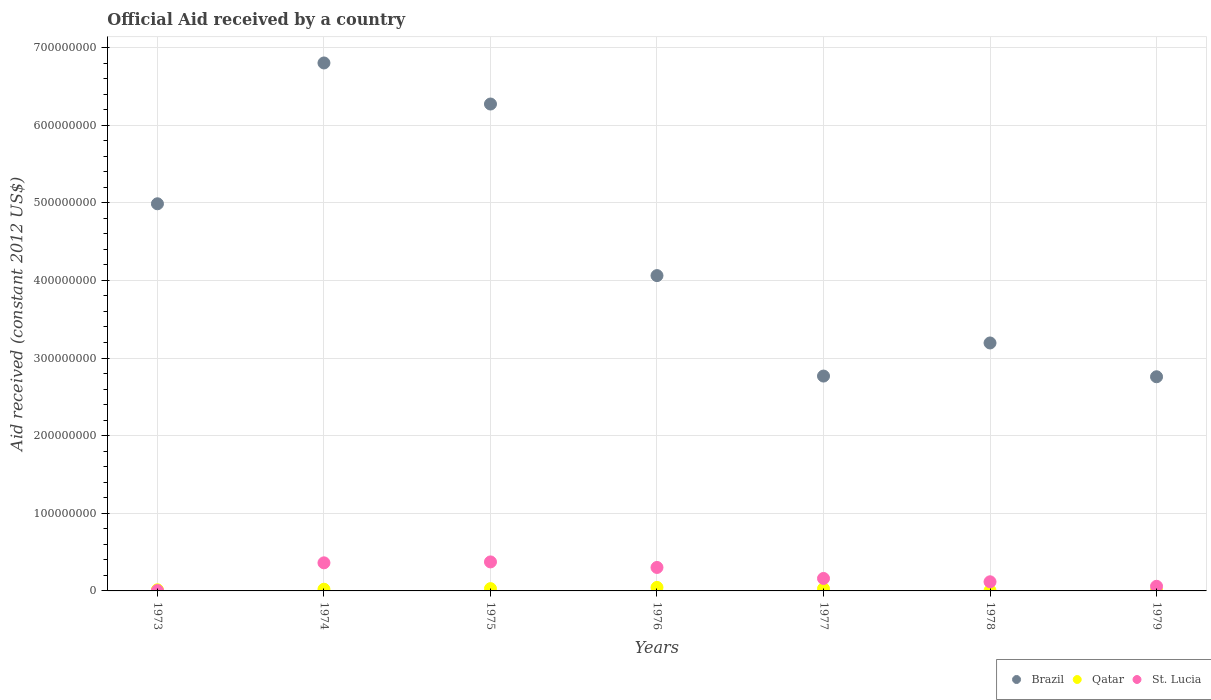How many different coloured dotlines are there?
Keep it short and to the point. 3. Is the number of dotlines equal to the number of legend labels?
Make the answer very short. Yes. What is the net official aid received in St. Lucia in 1974?
Your response must be concise. 3.62e+07. Across all years, what is the maximum net official aid received in Qatar?
Ensure brevity in your answer.  4.52e+06. In which year was the net official aid received in Brazil maximum?
Ensure brevity in your answer.  1974. In which year was the net official aid received in Brazil minimum?
Provide a short and direct response. 1979. What is the total net official aid received in St. Lucia in the graph?
Make the answer very short. 1.38e+08. What is the difference between the net official aid received in Qatar in 1973 and that in 1978?
Make the answer very short. 1.04e+06. What is the difference between the net official aid received in St. Lucia in 1979 and the net official aid received in Brazil in 1978?
Ensure brevity in your answer.  -3.13e+08. What is the average net official aid received in Qatar per year?
Keep it short and to the point. 2.12e+06. In the year 1973, what is the difference between the net official aid received in St. Lucia and net official aid received in Qatar?
Offer a terse response. -1.01e+06. In how many years, is the net official aid received in Brazil greater than 340000000 US$?
Ensure brevity in your answer.  4. What is the ratio of the net official aid received in Brazil in 1973 to that in 1978?
Offer a very short reply. 1.56. What is the difference between the highest and the second highest net official aid received in St. Lucia?
Your answer should be very brief. 1.19e+06. What is the difference between the highest and the lowest net official aid received in Brazil?
Give a very brief answer. 4.04e+08. In how many years, is the net official aid received in St. Lucia greater than the average net official aid received in St. Lucia taken over all years?
Make the answer very short. 3. Is it the case that in every year, the sum of the net official aid received in St. Lucia and net official aid received in Brazil  is greater than the net official aid received in Qatar?
Make the answer very short. Yes. Does the net official aid received in St. Lucia monotonically increase over the years?
Make the answer very short. No. How many years are there in the graph?
Keep it short and to the point. 7. What is the difference between two consecutive major ticks on the Y-axis?
Keep it short and to the point. 1.00e+08. Does the graph contain any zero values?
Your answer should be compact. No. Does the graph contain grids?
Offer a terse response. Yes. Where does the legend appear in the graph?
Make the answer very short. Bottom right. What is the title of the graph?
Offer a very short reply. Official Aid received by a country. Does "Dominica" appear as one of the legend labels in the graph?
Offer a very short reply. No. What is the label or title of the Y-axis?
Keep it short and to the point. Aid received (constant 2012 US$). What is the Aid received (constant 2012 US$) in Brazil in 1973?
Give a very brief answer. 4.99e+08. What is the Aid received (constant 2012 US$) of Qatar in 1973?
Provide a succinct answer. 1.44e+06. What is the Aid received (constant 2012 US$) in St. Lucia in 1973?
Provide a succinct answer. 4.30e+05. What is the Aid received (constant 2012 US$) of Brazil in 1974?
Ensure brevity in your answer.  6.80e+08. What is the Aid received (constant 2012 US$) of Qatar in 1974?
Make the answer very short. 2.20e+06. What is the Aid received (constant 2012 US$) in St. Lucia in 1974?
Make the answer very short. 3.62e+07. What is the Aid received (constant 2012 US$) in Brazil in 1975?
Your response must be concise. 6.27e+08. What is the Aid received (constant 2012 US$) of Qatar in 1975?
Provide a succinct answer. 2.96e+06. What is the Aid received (constant 2012 US$) of St. Lucia in 1975?
Offer a very short reply. 3.74e+07. What is the Aid received (constant 2012 US$) in Brazil in 1976?
Provide a short and direct response. 4.06e+08. What is the Aid received (constant 2012 US$) of Qatar in 1976?
Provide a succinct answer. 4.52e+06. What is the Aid received (constant 2012 US$) in St. Lucia in 1976?
Offer a terse response. 3.02e+07. What is the Aid received (constant 2012 US$) in Brazil in 1977?
Make the answer very short. 2.77e+08. What is the Aid received (constant 2012 US$) of Qatar in 1977?
Provide a short and direct response. 2.86e+06. What is the Aid received (constant 2012 US$) in St. Lucia in 1977?
Offer a very short reply. 1.61e+07. What is the Aid received (constant 2012 US$) in Brazil in 1978?
Offer a very short reply. 3.19e+08. What is the Aid received (constant 2012 US$) in Qatar in 1978?
Your answer should be very brief. 4.00e+05. What is the Aid received (constant 2012 US$) of St. Lucia in 1978?
Your answer should be compact. 1.18e+07. What is the Aid received (constant 2012 US$) in Brazil in 1979?
Your answer should be very brief. 2.76e+08. What is the Aid received (constant 2012 US$) in Qatar in 1979?
Provide a succinct answer. 4.40e+05. What is the Aid received (constant 2012 US$) in St. Lucia in 1979?
Offer a very short reply. 5.97e+06. Across all years, what is the maximum Aid received (constant 2012 US$) in Brazil?
Give a very brief answer. 6.80e+08. Across all years, what is the maximum Aid received (constant 2012 US$) of Qatar?
Your answer should be very brief. 4.52e+06. Across all years, what is the maximum Aid received (constant 2012 US$) in St. Lucia?
Provide a succinct answer. 3.74e+07. Across all years, what is the minimum Aid received (constant 2012 US$) of Brazil?
Provide a short and direct response. 2.76e+08. Across all years, what is the minimum Aid received (constant 2012 US$) in Qatar?
Keep it short and to the point. 4.00e+05. What is the total Aid received (constant 2012 US$) in Brazil in the graph?
Make the answer very short. 3.08e+09. What is the total Aid received (constant 2012 US$) in Qatar in the graph?
Offer a very short reply. 1.48e+07. What is the total Aid received (constant 2012 US$) in St. Lucia in the graph?
Give a very brief answer. 1.38e+08. What is the difference between the Aid received (constant 2012 US$) in Brazil in 1973 and that in 1974?
Provide a short and direct response. -1.81e+08. What is the difference between the Aid received (constant 2012 US$) of Qatar in 1973 and that in 1974?
Provide a short and direct response. -7.60e+05. What is the difference between the Aid received (constant 2012 US$) in St. Lucia in 1973 and that in 1974?
Provide a short and direct response. -3.58e+07. What is the difference between the Aid received (constant 2012 US$) in Brazil in 1973 and that in 1975?
Your response must be concise. -1.28e+08. What is the difference between the Aid received (constant 2012 US$) in Qatar in 1973 and that in 1975?
Your answer should be very brief. -1.52e+06. What is the difference between the Aid received (constant 2012 US$) in St. Lucia in 1973 and that in 1975?
Offer a terse response. -3.69e+07. What is the difference between the Aid received (constant 2012 US$) in Brazil in 1973 and that in 1976?
Provide a succinct answer. 9.25e+07. What is the difference between the Aid received (constant 2012 US$) of Qatar in 1973 and that in 1976?
Your answer should be very brief. -3.08e+06. What is the difference between the Aid received (constant 2012 US$) in St. Lucia in 1973 and that in 1976?
Give a very brief answer. -2.98e+07. What is the difference between the Aid received (constant 2012 US$) of Brazil in 1973 and that in 1977?
Provide a succinct answer. 2.22e+08. What is the difference between the Aid received (constant 2012 US$) in Qatar in 1973 and that in 1977?
Keep it short and to the point. -1.42e+06. What is the difference between the Aid received (constant 2012 US$) in St. Lucia in 1973 and that in 1977?
Your answer should be compact. -1.56e+07. What is the difference between the Aid received (constant 2012 US$) of Brazil in 1973 and that in 1978?
Offer a terse response. 1.79e+08. What is the difference between the Aid received (constant 2012 US$) in Qatar in 1973 and that in 1978?
Provide a short and direct response. 1.04e+06. What is the difference between the Aid received (constant 2012 US$) in St. Lucia in 1973 and that in 1978?
Ensure brevity in your answer.  -1.13e+07. What is the difference between the Aid received (constant 2012 US$) of Brazil in 1973 and that in 1979?
Give a very brief answer. 2.23e+08. What is the difference between the Aid received (constant 2012 US$) in Qatar in 1973 and that in 1979?
Your response must be concise. 1.00e+06. What is the difference between the Aid received (constant 2012 US$) of St. Lucia in 1973 and that in 1979?
Your answer should be very brief. -5.54e+06. What is the difference between the Aid received (constant 2012 US$) in Brazil in 1974 and that in 1975?
Give a very brief answer. 5.29e+07. What is the difference between the Aid received (constant 2012 US$) in Qatar in 1974 and that in 1975?
Offer a very short reply. -7.60e+05. What is the difference between the Aid received (constant 2012 US$) in St. Lucia in 1974 and that in 1975?
Ensure brevity in your answer.  -1.19e+06. What is the difference between the Aid received (constant 2012 US$) in Brazil in 1974 and that in 1976?
Provide a short and direct response. 2.74e+08. What is the difference between the Aid received (constant 2012 US$) in Qatar in 1974 and that in 1976?
Your response must be concise. -2.32e+06. What is the difference between the Aid received (constant 2012 US$) of St. Lucia in 1974 and that in 1976?
Keep it short and to the point. 5.95e+06. What is the difference between the Aid received (constant 2012 US$) in Brazil in 1974 and that in 1977?
Your answer should be compact. 4.03e+08. What is the difference between the Aid received (constant 2012 US$) of Qatar in 1974 and that in 1977?
Provide a short and direct response. -6.60e+05. What is the difference between the Aid received (constant 2012 US$) in St. Lucia in 1974 and that in 1977?
Offer a terse response. 2.01e+07. What is the difference between the Aid received (constant 2012 US$) in Brazil in 1974 and that in 1978?
Your answer should be very brief. 3.61e+08. What is the difference between the Aid received (constant 2012 US$) of Qatar in 1974 and that in 1978?
Provide a succinct answer. 1.80e+06. What is the difference between the Aid received (constant 2012 US$) of St. Lucia in 1974 and that in 1978?
Your response must be concise. 2.44e+07. What is the difference between the Aid received (constant 2012 US$) of Brazil in 1974 and that in 1979?
Offer a terse response. 4.04e+08. What is the difference between the Aid received (constant 2012 US$) in Qatar in 1974 and that in 1979?
Offer a terse response. 1.76e+06. What is the difference between the Aid received (constant 2012 US$) in St. Lucia in 1974 and that in 1979?
Provide a short and direct response. 3.02e+07. What is the difference between the Aid received (constant 2012 US$) of Brazil in 1975 and that in 1976?
Keep it short and to the point. 2.21e+08. What is the difference between the Aid received (constant 2012 US$) in Qatar in 1975 and that in 1976?
Your answer should be very brief. -1.56e+06. What is the difference between the Aid received (constant 2012 US$) of St. Lucia in 1975 and that in 1976?
Offer a terse response. 7.14e+06. What is the difference between the Aid received (constant 2012 US$) in Brazil in 1975 and that in 1977?
Keep it short and to the point. 3.50e+08. What is the difference between the Aid received (constant 2012 US$) in Qatar in 1975 and that in 1977?
Make the answer very short. 1.00e+05. What is the difference between the Aid received (constant 2012 US$) of St. Lucia in 1975 and that in 1977?
Keep it short and to the point. 2.13e+07. What is the difference between the Aid received (constant 2012 US$) of Brazil in 1975 and that in 1978?
Your answer should be compact. 3.08e+08. What is the difference between the Aid received (constant 2012 US$) in Qatar in 1975 and that in 1978?
Give a very brief answer. 2.56e+06. What is the difference between the Aid received (constant 2012 US$) in St. Lucia in 1975 and that in 1978?
Give a very brief answer. 2.56e+07. What is the difference between the Aid received (constant 2012 US$) of Brazil in 1975 and that in 1979?
Provide a succinct answer. 3.51e+08. What is the difference between the Aid received (constant 2012 US$) of Qatar in 1975 and that in 1979?
Ensure brevity in your answer.  2.52e+06. What is the difference between the Aid received (constant 2012 US$) of St. Lucia in 1975 and that in 1979?
Give a very brief answer. 3.14e+07. What is the difference between the Aid received (constant 2012 US$) of Brazil in 1976 and that in 1977?
Your response must be concise. 1.29e+08. What is the difference between the Aid received (constant 2012 US$) in Qatar in 1976 and that in 1977?
Give a very brief answer. 1.66e+06. What is the difference between the Aid received (constant 2012 US$) of St. Lucia in 1976 and that in 1977?
Ensure brevity in your answer.  1.42e+07. What is the difference between the Aid received (constant 2012 US$) of Brazil in 1976 and that in 1978?
Provide a succinct answer. 8.68e+07. What is the difference between the Aid received (constant 2012 US$) in Qatar in 1976 and that in 1978?
Your answer should be very brief. 4.12e+06. What is the difference between the Aid received (constant 2012 US$) in St. Lucia in 1976 and that in 1978?
Offer a very short reply. 1.85e+07. What is the difference between the Aid received (constant 2012 US$) in Brazil in 1976 and that in 1979?
Offer a very short reply. 1.30e+08. What is the difference between the Aid received (constant 2012 US$) in Qatar in 1976 and that in 1979?
Your answer should be very brief. 4.08e+06. What is the difference between the Aid received (constant 2012 US$) in St. Lucia in 1976 and that in 1979?
Provide a succinct answer. 2.43e+07. What is the difference between the Aid received (constant 2012 US$) in Brazil in 1977 and that in 1978?
Ensure brevity in your answer.  -4.26e+07. What is the difference between the Aid received (constant 2012 US$) of Qatar in 1977 and that in 1978?
Your response must be concise. 2.46e+06. What is the difference between the Aid received (constant 2012 US$) in St. Lucia in 1977 and that in 1978?
Provide a short and direct response. 4.29e+06. What is the difference between the Aid received (constant 2012 US$) of Qatar in 1977 and that in 1979?
Offer a very short reply. 2.42e+06. What is the difference between the Aid received (constant 2012 US$) of St. Lucia in 1977 and that in 1979?
Your answer should be very brief. 1.01e+07. What is the difference between the Aid received (constant 2012 US$) of Brazil in 1978 and that in 1979?
Offer a very short reply. 4.35e+07. What is the difference between the Aid received (constant 2012 US$) in Qatar in 1978 and that in 1979?
Ensure brevity in your answer.  -4.00e+04. What is the difference between the Aid received (constant 2012 US$) in St. Lucia in 1978 and that in 1979?
Your answer should be very brief. 5.80e+06. What is the difference between the Aid received (constant 2012 US$) of Brazil in 1973 and the Aid received (constant 2012 US$) of Qatar in 1974?
Your answer should be very brief. 4.96e+08. What is the difference between the Aid received (constant 2012 US$) in Brazil in 1973 and the Aid received (constant 2012 US$) in St. Lucia in 1974?
Ensure brevity in your answer.  4.62e+08. What is the difference between the Aid received (constant 2012 US$) of Qatar in 1973 and the Aid received (constant 2012 US$) of St. Lucia in 1974?
Your answer should be very brief. -3.47e+07. What is the difference between the Aid received (constant 2012 US$) in Brazil in 1973 and the Aid received (constant 2012 US$) in Qatar in 1975?
Your answer should be very brief. 4.96e+08. What is the difference between the Aid received (constant 2012 US$) in Brazil in 1973 and the Aid received (constant 2012 US$) in St. Lucia in 1975?
Provide a succinct answer. 4.61e+08. What is the difference between the Aid received (constant 2012 US$) in Qatar in 1973 and the Aid received (constant 2012 US$) in St. Lucia in 1975?
Provide a succinct answer. -3.59e+07. What is the difference between the Aid received (constant 2012 US$) in Brazil in 1973 and the Aid received (constant 2012 US$) in Qatar in 1976?
Offer a terse response. 4.94e+08. What is the difference between the Aid received (constant 2012 US$) in Brazil in 1973 and the Aid received (constant 2012 US$) in St. Lucia in 1976?
Offer a very short reply. 4.68e+08. What is the difference between the Aid received (constant 2012 US$) of Qatar in 1973 and the Aid received (constant 2012 US$) of St. Lucia in 1976?
Offer a terse response. -2.88e+07. What is the difference between the Aid received (constant 2012 US$) of Brazil in 1973 and the Aid received (constant 2012 US$) of Qatar in 1977?
Offer a very short reply. 4.96e+08. What is the difference between the Aid received (constant 2012 US$) of Brazil in 1973 and the Aid received (constant 2012 US$) of St. Lucia in 1977?
Offer a terse response. 4.83e+08. What is the difference between the Aid received (constant 2012 US$) in Qatar in 1973 and the Aid received (constant 2012 US$) in St. Lucia in 1977?
Ensure brevity in your answer.  -1.46e+07. What is the difference between the Aid received (constant 2012 US$) of Brazil in 1973 and the Aid received (constant 2012 US$) of Qatar in 1978?
Provide a succinct answer. 4.98e+08. What is the difference between the Aid received (constant 2012 US$) in Brazil in 1973 and the Aid received (constant 2012 US$) in St. Lucia in 1978?
Provide a succinct answer. 4.87e+08. What is the difference between the Aid received (constant 2012 US$) of Qatar in 1973 and the Aid received (constant 2012 US$) of St. Lucia in 1978?
Your response must be concise. -1.03e+07. What is the difference between the Aid received (constant 2012 US$) in Brazil in 1973 and the Aid received (constant 2012 US$) in Qatar in 1979?
Your answer should be very brief. 4.98e+08. What is the difference between the Aid received (constant 2012 US$) in Brazil in 1973 and the Aid received (constant 2012 US$) in St. Lucia in 1979?
Your response must be concise. 4.93e+08. What is the difference between the Aid received (constant 2012 US$) in Qatar in 1973 and the Aid received (constant 2012 US$) in St. Lucia in 1979?
Ensure brevity in your answer.  -4.53e+06. What is the difference between the Aid received (constant 2012 US$) of Brazil in 1974 and the Aid received (constant 2012 US$) of Qatar in 1975?
Provide a succinct answer. 6.77e+08. What is the difference between the Aid received (constant 2012 US$) in Brazil in 1974 and the Aid received (constant 2012 US$) in St. Lucia in 1975?
Keep it short and to the point. 6.43e+08. What is the difference between the Aid received (constant 2012 US$) of Qatar in 1974 and the Aid received (constant 2012 US$) of St. Lucia in 1975?
Offer a very short reply. -3.52e+07. What is the difference between the Aid received (constant 2012 US$) in Brazil in 1974 and the Aid received (constant 2012 US$) in Qatar in 1976?
Your answer should be very brief. 6.76e+08. What is the difference between the Aid received (constant 2012 US$) of Brazil in 1974 and the Aid received (constant 2012 US$) of St. Lucia in 1976?
Your answer should be compact. 6.50e+08. What is the difference between the Aid received (constant 2012 US$) in Qatar in 1974 and the Aid received (constant 2012 US$) in St. Lucia in 1976?
Provide a succinct answer. -2.80e+07. What is the difference between the Aid received (constant 2012 US$) in Brazil in 1974 and the Aid received (constant 2012 US$) in Qatar in 1977?
Ensure brevity in your answer.  6.77e+08. What is the difference between the Aid received (constant 2012 US$) in Brazil in 1974 and the Aid received (constant 2012 US$) in St. Lucia in 1977?
Give a very brief answer. 6.64e+08. What is the difference between the Aid received (constant 2012 US$) in Qatar in 1974 and the Aid received (constant 2012 US$) in St. Lucia in 1977?
Ensure brevity in your answer.  -1.39e+07. What is the difference between the Aid received (constant 2012 US$) in Brazil in 1974 and the Aid received (constant 2012 US$) in Qatar in 1978?
Your answer should be very brief. 6.80e+08. What is the difference between the Aid received (constant 2012 US$) of Brazil in 1974 and the Aid received (constant 2012 US$) of St. Lucia in 1978?
Give a very brief answer. 6.68e+08. What is the difference between the Aid received (constant 2012 US$) of Qatar in 1974 and the Aid received (constant 2012 US$) of St. Lucia in 1978?
Keep it short and to the point. -9.57e+06. What is the difference between the Aid received (constant 2012 US$) in Brazil in 1974 and the Aid received (constant 2012 US$) in Qatar in 1979?
Make the answer very short. 6.80e+08. What is the difference between the Aid received (constant 2012 US$) in Brazil in 1974 and the Aid received (constant 2012 US$) in St. Lucia in 1979?
Offer a terse response. 6.74e+08. What is the difference between the Aid received (constant 2012 US$) in Qatar in 1974 and the Aid received (constant 2012 US$) in St. Lucia in 1979?
Provide a succinct answer. -3.77e+06. What is the difference between the Aid received (constant 2012 US$) in Brazil in 1975 and the Aid received (constant 2012 US$) in Qatar in 1976?
Provide a succinct answer. 6.23e+08. What is the difference between the Aid received (constant 2012 US$) of Brazil in 1975 and the Aid received (constant 2012 US$) of St. Lucia in 1976?
Ensure brevity in your answer.  5.97e+08. What is the difference between the Aid received (constant 2012 US$) in Qatar in 1975 and the Aid received (constant 2012 US$) in St. Lucia in 1976?
Offer a terse response. -2.73e+07. What is the difference between the Aid received (constant 2012 US$) of Brazil in 1975 and the Aid received (constant 2012 US$) of Qatar in 1977?
Provide a short and direct response. 6.24e+08. What is the difference between the Aid received (constant 2012 US$) in Brazil in 1975 and the Aid received (constant 2012 US$) in St. Lucia in 1977?
Give a very brief answer. 6.11e+08. What is the difference between the Aid received (constant 2012 US$) in Qatar in 1975 and the Aid received (constant 2012 US$) in St. Lucia in 1977?
Make the answer very short. -1.31e+07. What is the difference between the Aid received (constant 2012 US$) of Brazil in 1975 and the Aid received (constant 2012 US$) of Qatar in 1978?
Your response must be concise. 6.27e+08. What is the difference between the Aid received (constant 2012 US$) of Brazil in 1975 and the Aid received (constant 2012 US$) of St. Lucia in 1978?
Make the answer very short. 6.15e+08. What is the difference between the Aid received (constant 2012 US$) in Qatar in 1975 and the Aid received (constant 2012 US$) in St. Lucia in 1978?
Your response must be concise. -8.81e+06. What is the difference between the Aid received (constant 2012 US$) in Brazil in 1975 and the Aid received (constant 2012 US$) in Qatar in 1979?
Your response must be concise. 6.27e+08. What is the difference between the Aid received (constant 2012 US$) in Brazil in 1975 and the Aid received (constant 2012 US$) in St. Lucia in 1979?
Provide a short and direct response. 6.21e+08. What is the difference between the Aid received (constant 2012 US$) in Qatar in 1975 and the Aid received (constant 2012 US$) in St. Lucia in 1979?
Offer a terse response. -3.01e+06. What is the difference between the Aid received (constant 2012 US$) in Brazil in 1976 and the Aid received (constant 2012 US$) in Qatar in 1977?
Ensure brevity in your answer.  4.03e+08. What is the difference between the Aid received (constant 2012 US$) in Brazil in 1976 and the Aid received (constant 2012 US$) in St. Lucia in 1977?
Provide a succinct answer. 3.90e+08. What is the difference between the Aid received (constant 2012 US$) in Qatar in 1976 and the Aid received (constant 2012 US$) in St. Lucia in 1977?
Offer a very short reply. -1.15e+07. What is the difference between the Aid received (constant 2012 US$) in Brazil in 1976 and the Aid received (constant 2012 US$) in Qatar in 1978?
Offer a terse response. 4.06e+08. What is the difference between the Aid received (constant 2012 US$) of Brazil in 1976 and the Aid received (constant 2012 US$) of St. Lucia in 1978?
Your answer should be very brief. 3.94e+08. What is the difference between the Aid received (constant 2012 US$) of Qatar in 1976 and the Aid received (constant 2012 US$) of St. Lucia in 1978?
Your response must be concise. -7.25e+06. What is the difference between the Aid received (constant 2012 US$) in Brazil in 1976 and the Aid received (constant 2012 US$) in Qatar in 1979?
Offer a very short reply. 4.06e+08. What is the difference between the Aid received (constant 2012 US$) in Brazil in 1976 and the Aid received (constant 2012 US$) in St. Lucia in 1979?
Offer a very short reply. 4.00e+08. What is the difference between the Aid received (constant 2012 US$) in Qatar in 1976 and the Aid received (constant 2012 US$) in St. Lucia in 1979?
Offer a very short reply. -1.45e+06. What is the difference between the Aid received (constant 2012 US$) of Brazil in 1977 and the Aid received (constant 2012 US$) of Qatar in 1978?
Provide a short and direct response. 2.76e+08. What is the difference between the Aid received (constant 2012 US$) in Brazil in 1977 and the Aid received (constant 2012 US$) in St. Lucia in 1978?
Your answer should be very brief. 2.65e+08. What is the difference between the Aid received (constant 2012 US$) of Qatar in 1977 and the Aid received (constant 2012 US$) of St. Lucia in 1978?
Provide a short and direct response. -8.91e+06. What is the difference between the Aid received (constant 2012 US$) in Brazil in 1977 and the Aid received (constant 2012 US$) in Qatar in 1979?
Your answer should be very brief. 2.76e+08. What is the difference between the Aid received (constant 2012 US$) of Brazil in 1977 and the Aid received (constant 2012 US$) of St. Lucia in 1979?
Ensure brevity in your answer.  2.71e+08. What is the difference between the Aid received (constant 2012 US$) in Qatar in 1977 and the Aid received (constant 2012 US$) in St. Lucia in 1979?
Make the answer very short. -3.11e+06. What is the difference between the Aid received (constant 2012 US$) in Brazil in 1978 and the Aid received (constant 2012 US$) in Qatar in 1979?
Ensure brevity in your answer.  3.19e+08. What is the difference between the Aid received (constant 2012 US$) in Brazil in 1978 and the Aid received (constant 2012 US$) in St. Lucia in 1979?
Keep it short and to the point. 3.13e+08. What is the difference between the Aid received (constant 2012 US$) of Qatar in 1978 and the Aid received (constant 2012 US$) of St. Lucia in 1979?
Give a very brief answer. -5.57e+06. What is the average Aid received (constant 2012 US$) in Brazil per year?
Your answer should be compact. 4.41e+08. What is the average Aid received (constant 2012 US$) of Qatar per year?
Your response must be concise. 2.12e+06. What is the average Aid received (constant 2012 US$) of St. Lucia per year?
Your answer should be compact. 1.97e+07. In the year 1973, what is the difference between the Aid received (constant 2012 US$) of Brazil and Aid received (constant 2012 US$) of Qatar?
Keep it short and to the point. 4.97e+08. In the year 1973, what is the difference between the Aid received (constant 2012 US$) in Brazil and Aid received (constant 2012 US$) in St. Lucia?
Make the answer very short. 4.98e+08. In the year 1973, what is the difference between the Aid received (constant 2012 US$) in Qatar and Aid received (constant 2012 US$) in St. Lucia?
Ensure brevity in your answer.  1.01e+06. In the year 1974, what is the difference between the Aid received (constant 2012 US$) in Brazil and Aid received (constant 2012 US$) in Qatar?
Offer a very short reply. 6.78e+08. In the year 1974, what is the difference between the Aid received (constant 2012 US$) in Brazil and Aid received (constant 2012 US$) in St. Lucia?
Provide a short and direct response. 6.44e+08. In the year 1974, what is the difference between the Aid received (constant 2012 US$) of Qatar and Aid received (constant 2012 US$) of St. Lucia?
Provide a short and direct response. -3.40e+07. In the year 1975, what is the difference between the Aid received (constant 2012 US$) of Brazil and Aid received (constant 2012 US$) of Qatar?
Your response must be concise. 6.24e+08. In the year 1975, what is the difference between the Aid received (constant 2012 US$) in Brazil and Aid received (constant 2012 US$) in St. Lucia?
Ensure brevity in your answer.  5.90e+08. In the year 1975, what is the difference between the Aid received (constant 2012 US$) of Qatar and Aid received (constant 2012 US$) of St. Lucia?
Provide a succinct answer. -3.44e+07. In the year 1976, what is the difference between the Aid received (constant 2012 US$) of Brazil and Aid received (constant 2012 US$) of Qatar?
Offer a terse response. 4.02e+08. In the year 1976, what is the difference between the Aid received (constant 2012 US$) in Brazil and Aid received (constant 2012 US$) in St. Lucia?
Give a very brief answer. 3.76e+08. In the year 1976, what is the difference between the Aid received (constant 2012 US$) in Qatar and Aid received (constant 2012 US$) in St. Lucia?
Give a very brief answer. -2.57e+07. In the year 1977, what is the difference between the Aid received (constant 2012 US$) of Brazil and Aid received (constant 2012 US$) of Qatar?
Keep it short and to the point. 2.74e+08. In the year 1977, what is the difference between the Aid received (constant 2012 US$) in Brazil and Aid received (constant 2012 US$) in St. Lucia?
Your answer should be compact. 2.61e+08. In the year 1977, what is the difference between the Aid received (constant 2012 US$) of Qatar and Aid received (constant 2012 US$) of St. Lucia?
Your answer should be compact. -1.32e+07. In the year 1978, what is the difference between the Aid received (constant 2012 US$) of Brazil and Aid received (constant 2012 US$) of Qatar?
Ensure brevity in your answer.  3.19e+08. In the year 1978, what is the difference between the Aid received (constant 2012 US$) of Brazil and Aid received (constant 2012 US$) of St. Lucia?
Give a very brief answer. 3.08e+08. In the year 1978, what is the difference between the Aid received (constant 2012 US$) in Qatar and Aid received (constant 2012 US$) in St. Lucia?
Offer a terse response. -1.14e+07. In the year 1979, what is the difference between the Aid received (constant 2012 US$) of Brazil and Aid received (constant 2012 US$) of Qatar?
Offer a terse response. 2.75e+08. In the year 1979, what is the difference between the Aid received (constant 2012 US$) of Brazil and Aid received (constant 2012 US$) of St. Lucia?
Provide a short and direct response. 2.70e+08. In the year 1979, what is the difference between the Aid received (constant 2012 US$) in Qatar and Aid received (constant 2012 US$) in St. Lucia?
Your answer should be very brief. -5.53e+06. What is the ratio of the Aid received (constant 2012 US$) of Brazil in 1973 to that in 1974?
Keep it short and to the point. 0.73. What is the ratio of the Aid received (constant 2012 US$) in Qatar in 1973 to that in 1974?
Give a very brief answer. 0.65. What is the ratio of the Aid received (constant 2012 US$) in St. Lucia in 1973 to that in 1974?
Make the answer very short. 0.01. What is the ratio of the Aid received (constant 2012 US$) of Brazil in 1973 to that in 1975?
Ensure brevity in your answer.  0.8. What is the ratio of the Aid received (constant 2012 US$) of Qatar in 1973 to that in 1975?
Your answer should be very brief. 0.49. What is the ratio of the Aid received (constant 2012 US$) of St. Lucia in 1973 to that in 1975?
Ensure brevity in your answer.  0.01. What is the ratio of the Aid received (constant 2012 US$) in Brazil in 1973 to that in 1976?
Your answer should be compact. 1.23. What is the ratio of the Aid received (constant 2012 US$) of Qatar in 1973 to that in 1976?
Make the answer very short. 0.32. What is the ratio of the Aid received (constant 2012 US$) in St. Lucia in 1973 to that in 1976?
Give a very brief answer. 0.01. What is the ratio of the Aid received (constant 2012 US$) of Brazil in 1973 to that in 1977?
Your answer should be compact. 1.8. What is the ratio of the Aid received (constant 2012 US$) of Qatar in 1973 to that in 1977?
Ensure brevity in your answer.  0.5. What is the ratio of the Aid received (constant 2012 US$) in St. Lucia in 1973 to that in 1977?
Your answer should be very brief. 0.03. What is the ratio of the Aid received (constant 2012 US$) of Brazil in 1973 to that in 1978?
Keep it short and to the point. 1.56. What is the ratio of the Aid received (constant 2012 US$) in Qatar in 1973 to that in 1978?
Provide a short and direct response. 3.6. What is the ratio of the Aid received (constant 2012 US$) of St. Lucia in 1973 to that in 1978?
Ensure brevity in your answer.  0.04. What is the ratio of the Aid received (constant 2012 US$) of Brazil in 1973 to that in 1979?
Ensure brevity in your answer.  1.81. What is the ratio of the Aid received (constant 2012 US$) in Qatar in 1973 to that in 1979?
Provide a succinct answer. 3.27. What is the ratio of the Aid received (constant 2012 US$) in St. Lucia in 1973 to that in 1979?
Make the answer very short. 0.07. What is the ratio of the Aid received (constant 2012 US$) in Brazil in 1974 to that in 1975?
Make the answer very short. 1.08. What is the ratio of the Aid received (constant 2012 US$) in Qatar in 1974 to that in 1975?
Provide a short and direct response. 0.74. What is the ratio of the Aid received (constant 2012 US$) in St. Lucia in 1974 to that in 1975?
Provide a short and direct response. 0.97. What is the ratio of the Aid received (constant 2012 US$) in Brazil in 1974 to that in 1976?
Ensure brevity in your answer.  1.67. What is the ratio of the Aid received (constant 2012 US$) of Qatar in 1974 to that in 1976?
Provide a succinct answer. 0.49. What is the ratio of the Aid received (constant 2012 US$) of St. Lucia in 1974 to that in 1976?
Keep it short and to the point. 1.2. What is the ratio of the Aid received (constant 2012 US$) in Brazil in 1974 to that in 1977?
Offer a very short reply. 2.46. What is the ratio of the Aid received (constant 2012 US$) in Qatar in 1974 to that in 1977?
Your response must be concise. 0.77. What is the ratio of the Aid received (constant 2012 US$) in St. Lucia in 1974 to that in 1977?
Provide a short and direct response. 2.25. What is the ratio of the Aid received (constant 2012 US$) of Brazil in 1974 to that in 1978?
Offer a very short reply. 2.13. What is the ratio of the Aid received (constant 2012 US$) in Qatar in 1974 to that in 1978?
Ensure brevity in your answer.  5.5. What is the ratio of the Aid received (constant 2012 US$) of St. Lucia in 1974 to that in 1978?
Your answer should be compact. 3.07. What is the ratio of the Aid received (constant 2012 US$) in Brazil in 1974 to that in 1979?
Offer a terse response. 2.47. What is the ratio of the Aid received (constant 2012 US$) of St. Lucia in 1974 to that in 1979?
Give a very brief answer. 6.06. What is the ratio of the Aid received (constant 2012 US$) of Brazil in 1975 to that in 1976?
Ensure brevity in your answer.  1.54. What is the ratio of the Aid received (constant 2012 US$) in Qatar in 1975 to that in 1976?
Keep it short and to the point. 0.65. What is the ratio of the Aid received (constant 2012 US$) of St. Lucia in 1975 to that in 1976?
Your answer should be compact. 1.24. What is the ratio of the Aid received (constant 2012 US$) in Brazil in 1975 to that in 1977?
Provide a succinct answer. 2.27. What is the ratio of the Aid received (constant 2012 US$) of Qatar in 1975 to that in 1977?
Your response must be concise. 1.03. What is the ratio of the Aid received (constant 2012 US$) of St. Lucia in 1975 to that in 1977?
Your answer should be very brief. 2.33. What is the ratio of the Aid received (constant 2012 US$) in Brazil in 1975 to that in 1978?
Give a very brief answer. 1.96. What is the ratio of the Aid received (constant 2012 US$) of Qatar in 1975 to that in 1978?
Offer a very short reply. 7.4. What is the ratio of the Aid received (constant 2012 US$) in St. Lucia in 1975 to that in 1978?
Provide a succinct answer. 3.17. What is the ratio of the Aid received (constant 2012 US$) of Brazil in 1975 to that in 1979?
Your answer should be compact. 2.27. What is the ratio of the Aid received (constant 2012 US$) of Qatar in 1975 to that in 1979?
Keep it short and to the point. 6.73. What is the ratio of the Aid received (constant 2012 US$) in St. Lucia in 1975 to that in 1979?
Ensure brevity in your answer.  6.26. What is the ratio of the Aid received (constant 2012 US$) of Brazil in 1976 to that in 1977?
Offer a terse response. 1.47. What is the ratio of the Aid received (constant 2012 US$) of Qatar in 1976 to that in 1977?
Make the answer very short. 1.58. What is the ratio of the Aid received (constant 2012 US$) in St. Lucia in 1976 to that in 1977?
Your response must be concise. 1.88. What is the ratio of the Aid received (constant 2012 US$) of Brazil in 1976 to that in 1978?
Provide a short and direct response. 1.27. What is the ratio of the Aid received (constant 2012 US$) of Qatar in 1976 to that in 1978?
Provide a succinct answer. 11.3. What is the ratio of the Aid received (constant 2012 US$) of St. Lucia in 1976 to that in 1978?
Offer a very short reply. 2.57. What is the ratio of the Aid received (constant 2012 US$) of Brazil in 1976 to that in 1979?
Ensure brevity in your answer.  1.47. What is the ratio of the Aid received (constant 2012 US$) in Qatar in 1976 to that in 1979?
Ensure brevity in your answer.  10.27. What is the ratio of the Aid received (constant 2012 US$) of St. Lucia in 1976 to that in 1979?
Offer a very short reply. 5.06. What is the ratio of the Aid received (constant 2012 US$) of Brazil in 1977 to that in 1978?
Offer a very short reply. 0.87. What is the ratio of the Aid received (constant 2012 US$) in Qatar in 1977 to that in 1978?
Ensure brevity in your answer.  7.15. What is the ratio of the Aid received (constant 2012 US$) of St. Lucia in 1977 to that in 1978?
Ensure brevity in your answer.  1.36. What is the ratio of the Aid received (constant 2012 US$) of Brazil in 1977 to that in 1979?
Offer a terse response. 1. What is the ratio of the Aid received (constant 2012 US$) of Qatar in 1977 to that in 1979?
Your answer should be very brief. 6.5. What is the ratio of the Aid received (constant 2012 US$) of St. Lucia in 1977 to that in 1979?
Make the answer very short. 2.69. What is the ratio of the Aid received (constant 2012 US$) of Brazil in 1978 to that in 1979?
Ensure brevity in your answer.  1.16. What is the ratio of the Aid received (constant 2012 US$) in St. Lucia in 1978 to that in 1979?
Ensure brevity in your answer.  1.97. What is the difference between the highest and the second highest Aid received (constant 2012 US$) of Brazil?
Provide a succinct answer. 5.29e+07. What is the difference between the highest and the second highest Aid received (constant 2012 US$) in Qatar?
Offer a very short reply. 1.56e+06. What is the difference between the highest and the second highest Aid received (constant 2012 US$) of St. Lucia?
Provide a succinct answer. 1.19e+06. What is the difference between the highest and the lowest Aid received (constant 2012 US$) in Brazil?
Keep it short and to the point. 4.04e+08. What is the difference between the highest and the lowest Aid received (constant 2012 US$) of Qatar?
Keep it short and to the point. 4.12e+06. What is the difference between the highest and the lowest Aid received (constant 2012 US$) in St. Lucia?
Offer a very short reply. 3.69e+07. 